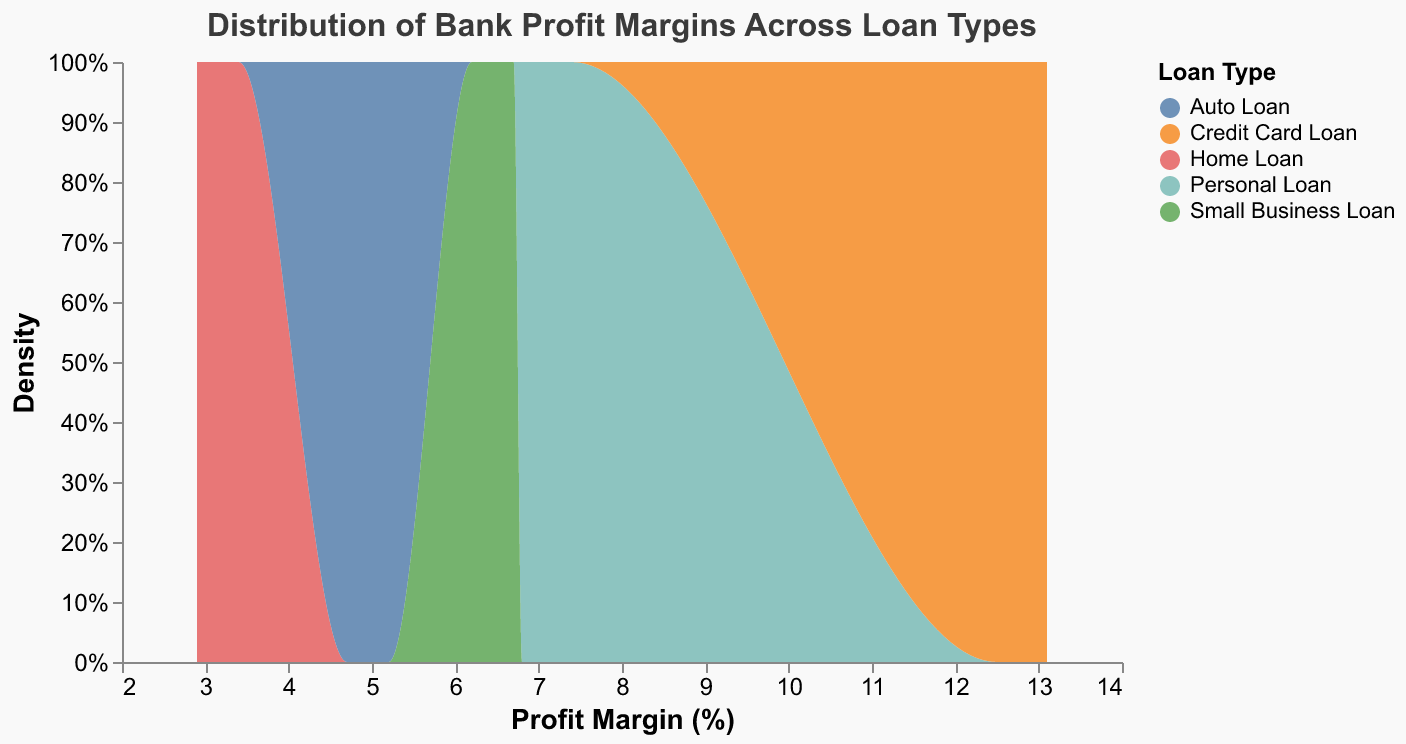What is the title of the plot? The title is displayed at the top of the chart. From what's given, it is clearly mentioned as "Distribution of Bank Profit Margins Across Loan Types"
Answer: Distribution of Bank Profit Margins Across Loan Types What does the x-axis represent in the plot? The x-axis represents a quantitative measure. According to the provided data and code, it measures "Profit Margin (%)". This is evident from the axis title in the code.
Answer: Profit Margin (%) Which loan type has the highest profit margin? To determine this, we need to look at the highest peak on the x-axis for each loan type represented by different colors. The Credit Card Loan type peaks the highest with margins around 13.0%.
Answer: Credit Card Loan What is the range of profit margins for Personal Loans? Observing the area representing Personal Loans tells us the range is between the lowest and highest points on the x-axis. Personal Loans range from approximately 6.8% to 7.4%.
Answer: 6.8% to 7.4% How does the profit margin of Home Loans compare to Auto Loans? By comparing the peaks and spread of the density areas, Home Loans have profit margins between 2.9% and 3.4%, while Auto Loans range from 4.7% to 5.2%. Therefore, Auto Loans generally have a higher profit margin than Home Loans.
Answer: Auto Loans have higher profit margins Which loan type appears to have the most stable profit margins based on the density plot? The stability of profit margins can be inferred by the narrowness of the density area. Both Home Loans and Auto Loans display a more concentrated range (narrower spread), indicating greater stability by comparison to others which might have wider spreads.
Answer: Home Loans and Auto Loans What does the y-axis indicate on this density plot? The y-axis denotes the normalized density of data points. It shows the proportion of the data that falls within each range of profit margins. This can be inferred from the axis label "Density" and the normalization in the encoding section.
Answer: Normalized Density Between Personal Loans and Small Business Loans, which has a wider range of profit margins? By observing the widths of the density areas on the x-axis, Personal Loans range from 6.8% to 7.4%, while Small Business Loans range from 6.2% to 6.7%. Thus, Personal Loans have a wider range of profit margins than Small Business Loans.
Answer: Personal Loans How do the profit margins of Chase compare across different loan types? From the data provided, we see Chase's profit margins for each loan type: Home Loan (3.4%), Auto Loan (5.0%), Personal Loan (7.4%), Small Business Loan (6.5%), and Credit Card Loan (12.5%). So, the comparison shows significant variance across loan types.
Answer: Varies significantly Which loan type has the narrowest range of profit margins and what is that range? By assessing the density plots, the narrowest range can be identified where the area is the most compressed. Home Loans have the narrowest range, from 2.9% to 3.4%.
Answer: Home Loans (2.9% to 3.4%) 